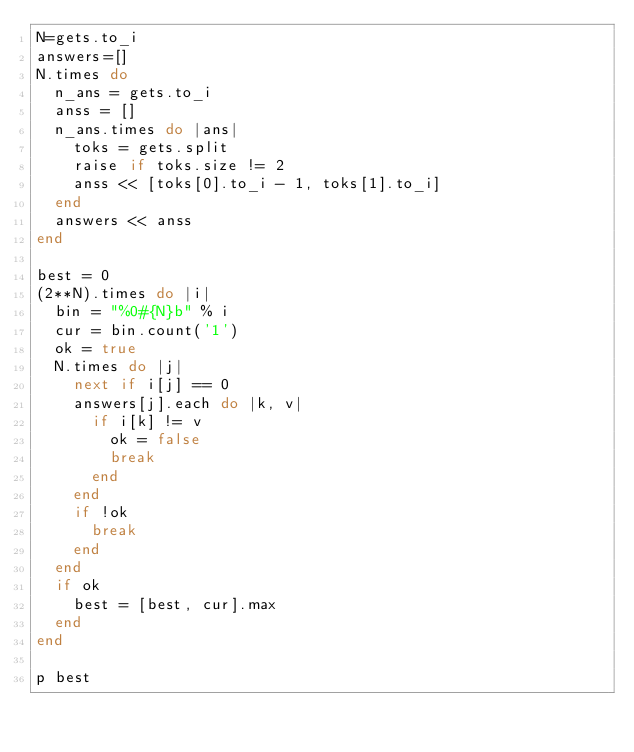<code> <loc_0><loc_0><loc_500><loc_500><_Ruby_>N=gets.to_i
answers=[]
N.times do
  n_ans = gets.to_i
  anss = []
  n_ans.times do |ans|
    toks = gets.split
    raise if toks.size != 2
    anss << [toks[0].to_i - 1, toks[1].to_i]
  end
  answers << anss
end

best = 0
(2**N).times do |i|
  bin = "%0#{N}b" % i
  cur = bin.count('1')
  ok = true
  N.times do |j|
    next if i[j] == 0
    answers[j].each do |k, v|
      if i[k] != v
        ok = false
        break
      end
    end
    if !ok
      break
    end
  end
  if ok
    best = [best, cur].max
  end
end

p best

</code> 